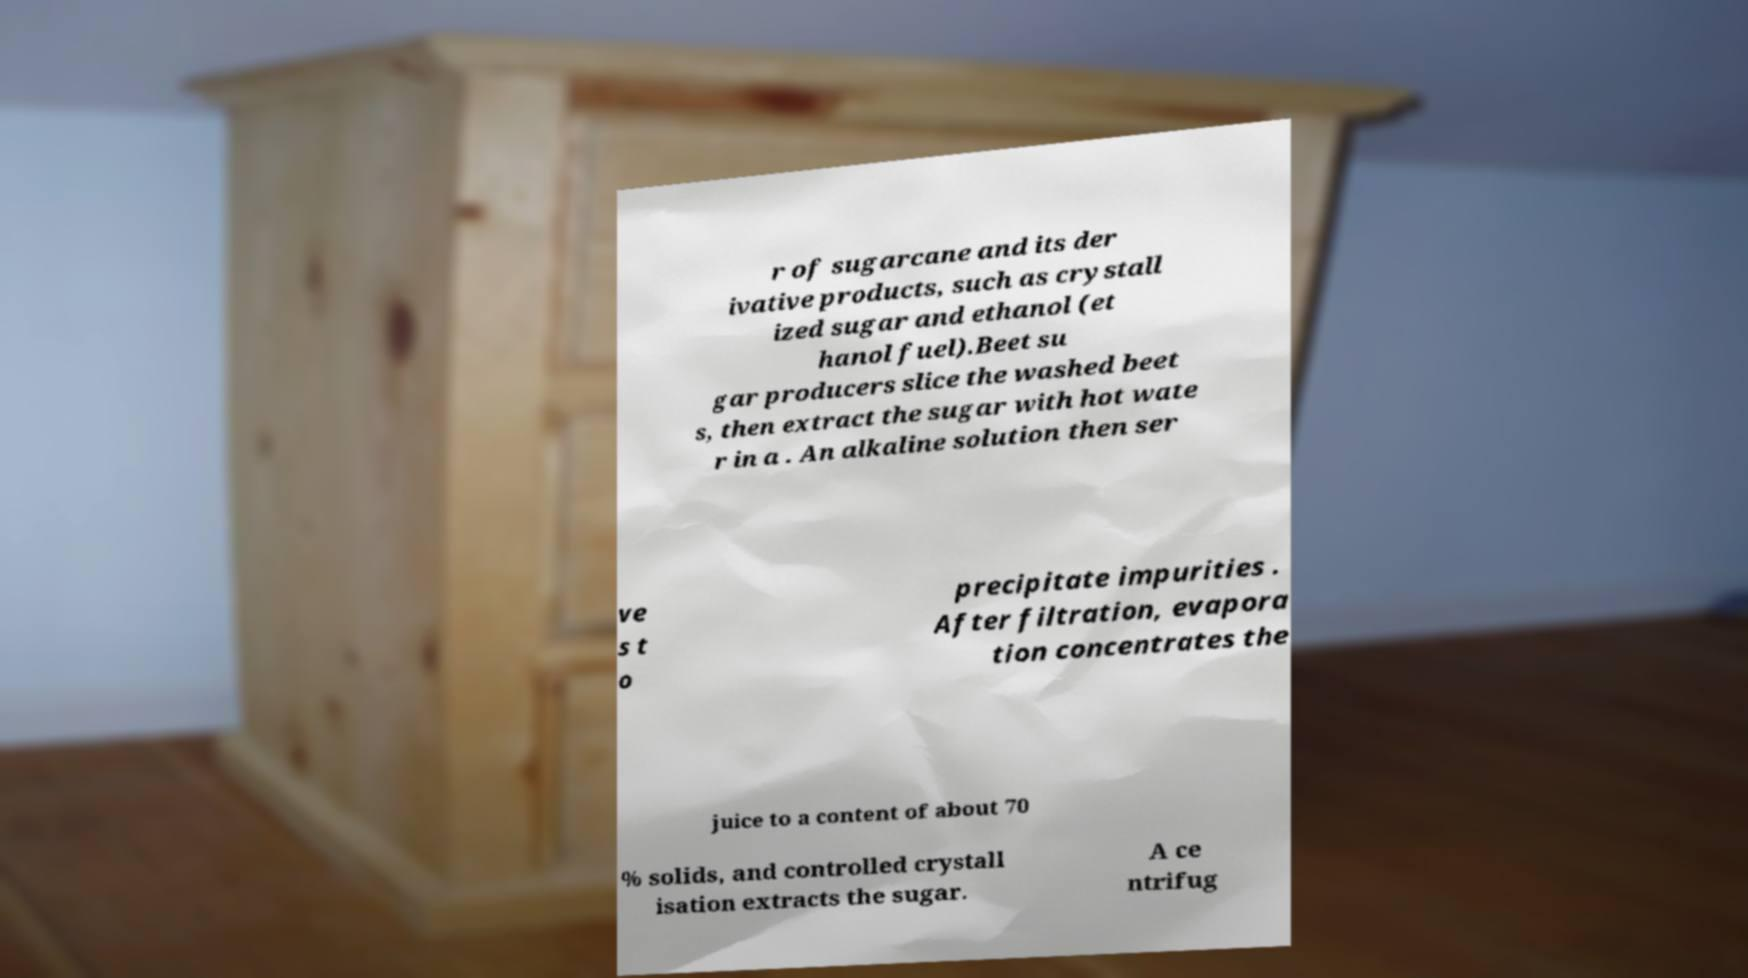Please identify and transcribe the text found in this image. r of sugarcane and its der ivative products, such as crystall ized sugar and ethanol (et hanol fuel).Beet su gar producers slice the washed beet s, then extract the sugar with hot wate r in a . An alkaline solution then ser ve s t o precipitate impurities . After filtration, evapora tion concentrates the juice to a content of about 70 % solids, and controlled crystall isation extracts the sugar. A ce ntrifug 